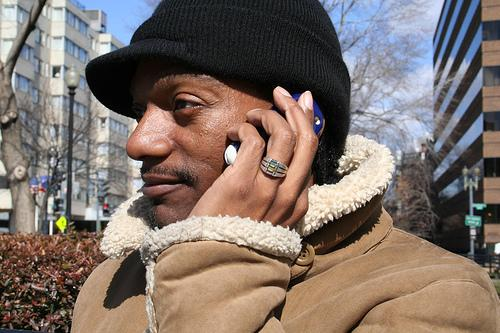Summarize the main focus of the image and the action taking place. A man is talking on his blue and white cell phone, while wearing a brown jacket, a black hat, and a large ring on his finger. What's the most noticeable atmosphere or vibes of the image? The image creates an urban, street-style vibe mainly due to the man's clothing, accessories, and usage of the cell phone. Describe the clothing, accessories, and activity of the main subject in this image. The main subject is wearing a light brown jacket with white sheep wool lining, a black hat, and a large ring on his finger, whilst talking on a blue and white cell phone. Explain the primary scene in the picture and the individual's activity. The main scene features a man holding a blue and white cell phone to his ear, wearing a light brown coat, a black cap, and a big ring on his hand. Analyze the image and explain the central theme and the ongoing activity. The central theme revolves around a stylish man with a mustache, holding a blue and white phone, wearing a brown jacket with sheep wool, black hat, and a prominent ring, engaged in a phone call. Identify the major subject and describe their clothing, appearance and actions. The major subject is a man, who is wearing a brown jacket with sheep wool lining and a black hat, holding a blue and white cell phone to his ear, and has a large ring on his finger. What are some notable aspects of the central character's appearance and what are they doing? Some notable aspects include the man's mustache, light brown coat, black hat, conspicuous ring, and him using a blue and white cell phone for talking. Capture the essentials of the image's content, with emphasis on the person and their actions. A mustached man in a sheep wool-lined brown jacket and black hat is busy on a call, using his blue and white cell phone, and has a prominent ring on his finger. What does the primary figure in the photograph look like and what are they involved in? The primary figure is a man dressed in a brown coat with sheep wool, black cap, and a sizeable ring, engaged in a conversation on his blue and white cell phone. Highlight the central character's appearance and what they are engaged in. A man with a mustache, wearing a black hat and a brown jacket with sheep wool, is talking on his blue and white cell phone, with a large ring on his finger. Pay attention to a tree with yellow leaves behind the red shrubbery. This instruction is misleading since it specifies a tree with yellow leaves, while the image contains a tree behind shrubbery but no information about its leaves' color. Look for a traffic light standing next to the white fence. This instruction is misleading since there are traffic lights in the image but no information about a white fence. Can you see a blue building in the background? There is a building in the image, but its color is not mentioned as blue. Is the man with a mustache wearing a blue hat? This instruction is misleading because the man wearing a hat is described as wearing a black hat, not a blue hat. Find a tall streetlamp painted in red. This instruction is misleading because while there is a tall streetlamp in the image, it is not stated to be painted in red. Doesn't the large ring on the hand have a green gemstone? No, it's not mentioned in the image. Find the woman wearing a white cap. This instruction is misleading because there is a man wearing a black hat, not a woman wearing a white cap. Notice the man holding a cell phone, he seems to be wearing a green jacket. This instruction is misleading since the man is described wearing a brown jacket or a light brown coat, not a green one. Did you see a woman holding a purple cell phone? This instruction introduces two inaccuracies: the person holding the phone is a man and the cell phone is blue and white, not purple. 